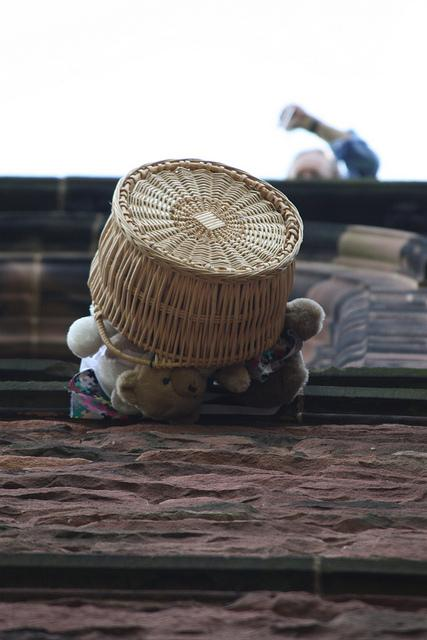What is the wicker basket covering on top of? Please explain your reasoning. teddy bears. The basket covers teddy bears. 